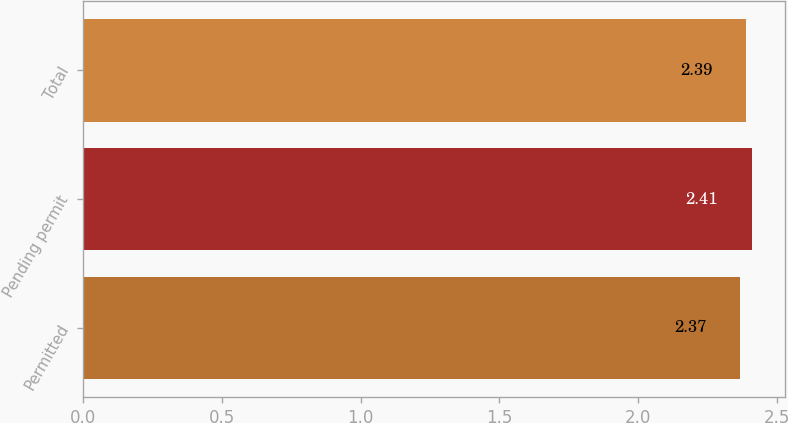Convert chart. <chart><loc_0><loc_0><loc_500><loc_500><bar_chart><fcel>Permitted<fcel>Pending permit<fcel>Total<nl><fcel>2.37<fcel>2.41<fcel>2.39<nl></chart> 